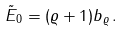<formula> <loc_0><loc_0><loc_500><loc_500>\tilde { E } _ { 0 } = ( \varrho + 1 ) b _ { \varrho } \, .</formula> 